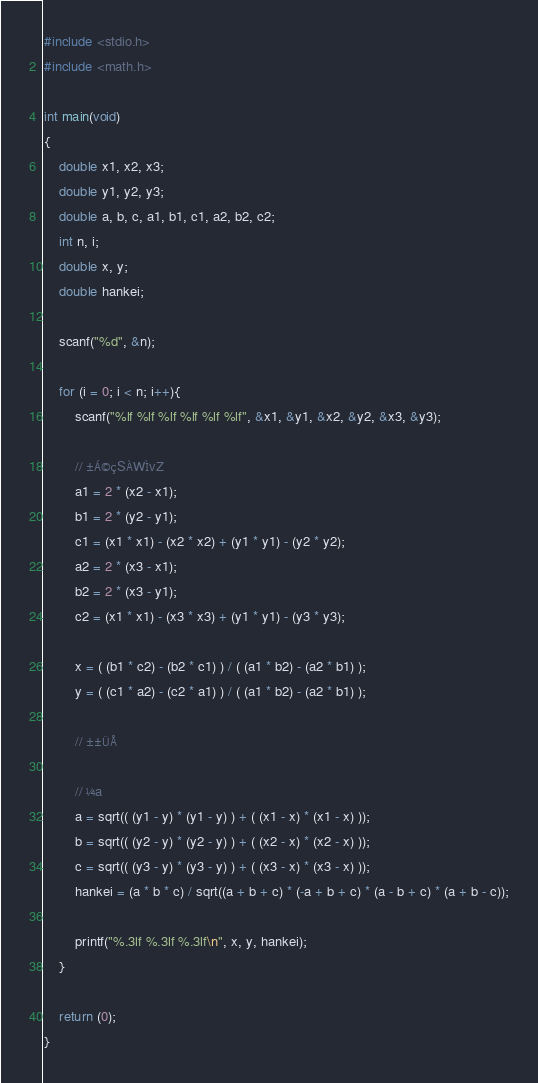Convert code to text. <code><loc_0><loc_0><loc_500><loc_500><_C_>#include <stdio.h>
#include <math.h>

int main(void)
{
	double x1, x2, x3;
	double y1, y2, y3;
	double a, b, c, a1, b1, c1, a2, b2, c2;
	int n, i;
	double x, y;
	double hankei;
	
	scanf("%d", &n);
	
	for (i = 0; i < n; i++){
		scanf("%lf %lf %lf %lf %lf %lf", &x1, &y1, &x2, &y2, &x3, &y3);
		
		// ±Á©çSÀWÌvZ
		a1 = 2 * (x2 - x1);
		b1 = 2 * (y2 - y1);
		c1 = (x1 * x1) - (x2 * x2) + (y1 * y1) - (y2 * y2);
		a2 = 2 * (x3 - x1);
		b2 = 2 * (x3 - y1);
		c2 = (x1 * x1) - (x3 * x3) + (y1 * y1) - (y3 * y3);
		
		x = ( (b1 * c2) - (b2 * c1) ) / ( (a1 * b2) - (a2 * b1) );
		y = ( (c1 * a2) - (c2 * a1) ) / ( (a1 * b2) - (a2 * b1) );
		
		// ±±ÜÅ
		
		// ¼a
		a = sqrt(( (y1 - y) * (y1 - y) ) + ( (x1 - x) * (x1 - x) ));
		b = sqrt(( (y2 - y) * (y2 - y) ) + ( (x2 - x) * (x2 - x) ));
		c = sqrt(( (y3 - y) * (y3 - y) ) + ( (x3 - x) * (x3 - x) ));
		hankei = (a * b * c) / sqrt((a + b + c) * (-a + b + c) * (a - b + c) * (a + b - c));
		
		printf("%.3lf %.3lf %.3lf\n", x, y, hankei);
	}
	
	return (0);
}</code> 